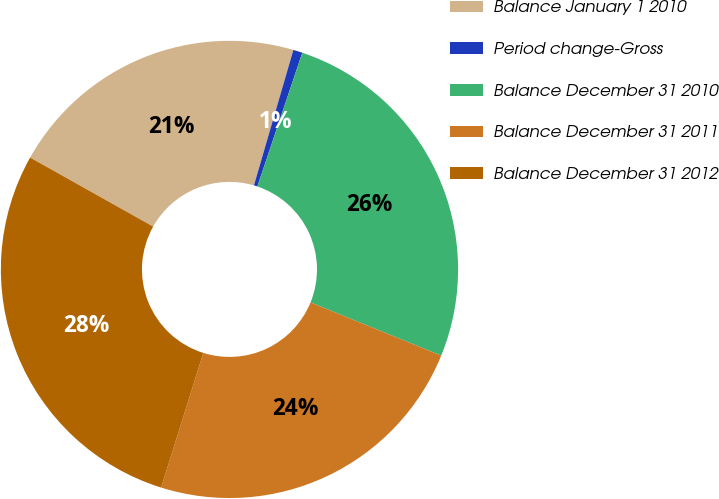<chart> <loc_0><loc_0><loc_500><loc_500><pie_chart><fcel>Balance January 1 2010<fcel>Period change-Gross<fcel>Balance December 31 2010<fcel>Balance December 31 2011<fcel>Balance December 31 2012<nl><fcel>21.37%<fcel>0.65%<fcel>25.99%<fcel>23.68%<fcel>28.3%<nl></chart> 